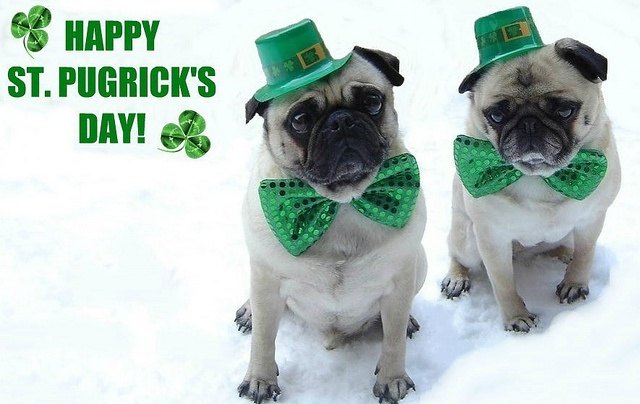Describe the objects in this image and their specific colors. I can see dog in white, darkgray, black, gray, and lightgray tones, dog in white, darkgray, gray, black, and lightgray tones, tie in white, darkgreen, green, and teal tones, and tie in white, green, darkgreen, and teal tones in this image. 